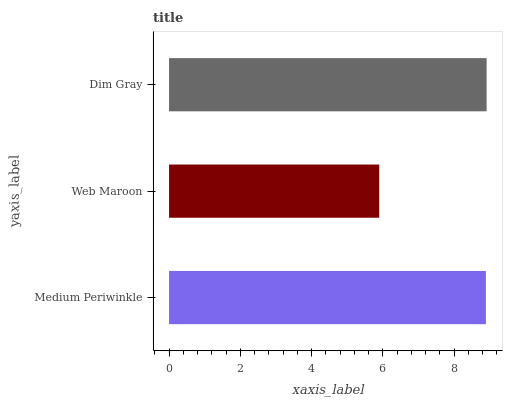Is Web Maroon the minimum?
Answer yes or no. Yes. Is Dim Gray the maximum?
Answer yes or no. Yes. Is Dim Gray the minimum?
Answer yes or no. No. Is Web Maroon the maximum?
Answer yes or no. No. Is Dim Gray greater than Web Maroon?
Answer yes or no. Yes. Is Web Maroon less than Dim Gray?
Answer yes or no. Yes. Is Web Maroon greater than Dim Gray?
Answer yes or no. No. Is Dim Gray less than Web Maroon?
Answer yes or no. No. Is Medium Periwinkle the high median?
Answer yes or no. Yes. Is Medium Periwinkle the low median?
Answer yes or no. Yes. Is Web Maroon the high median?
Answer yes or no. No. Is Dim Gray the low median?
Answer yes or no. No. 